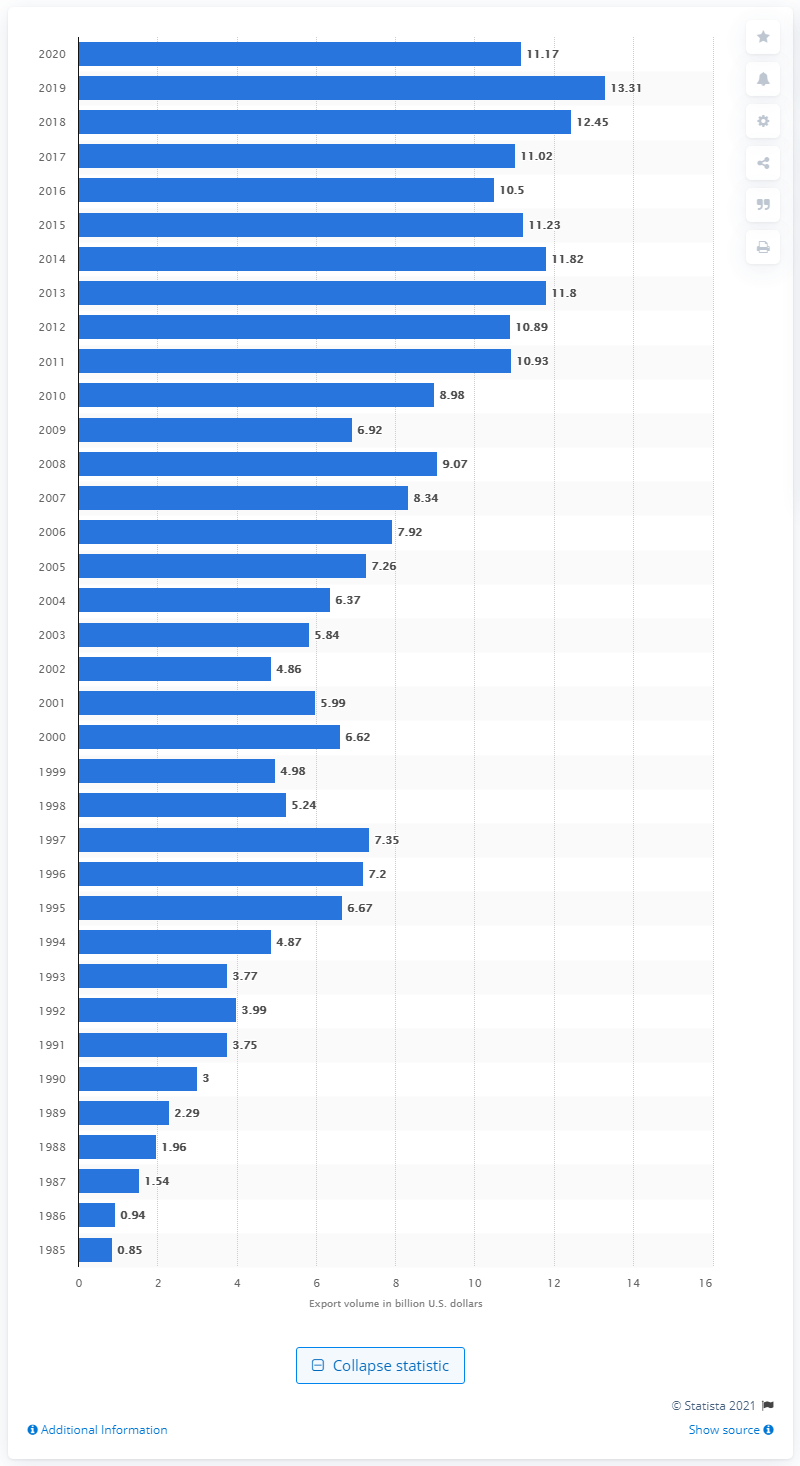Give some essential details in this illustration. In 2020, the value of U.S. exports to Thailand was $11.17 billion. 